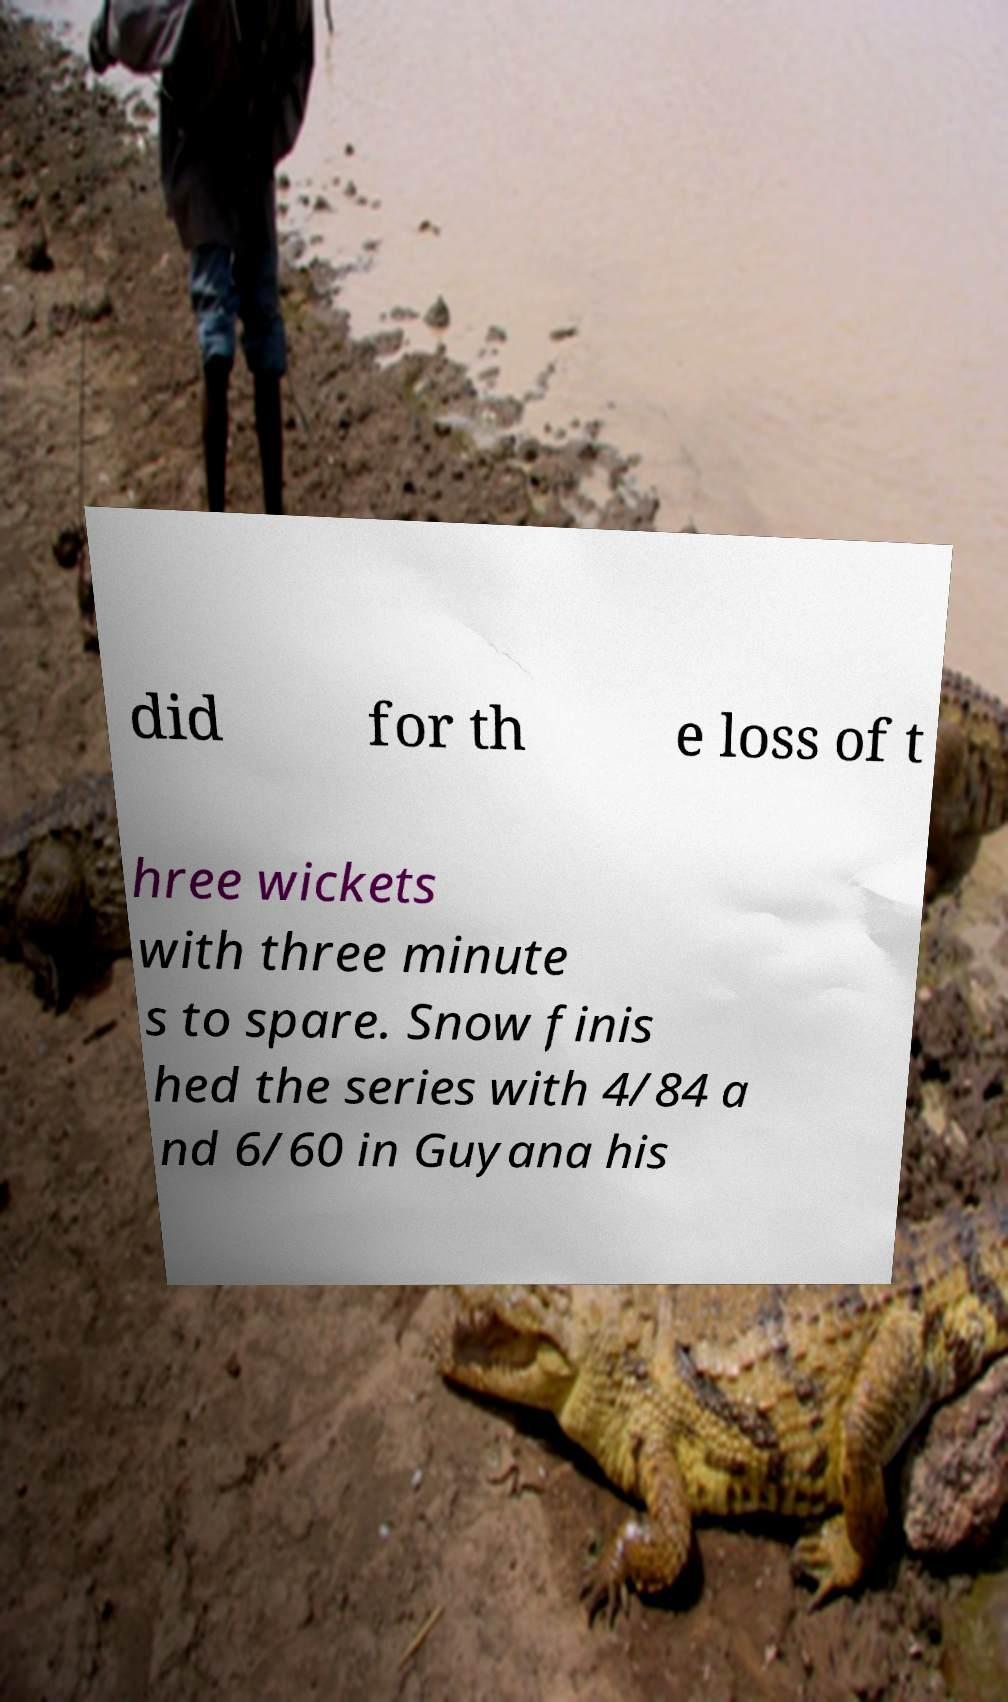Can you accurately transcribe the text from the provided image for me? did for th e loss of t hree wickets with three minute s to spare. Snow finis hed the series with 4/84 a nd 6/60 in Guyana his 